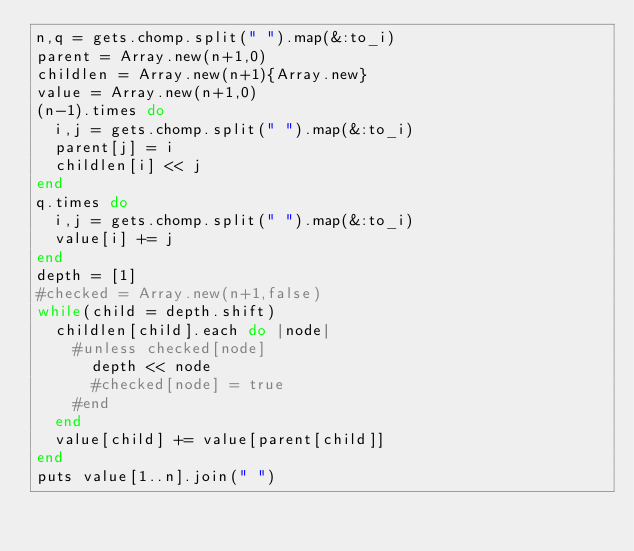Convert code to text. <code><loc_0><loc_0><loc_500><loc_500><_Ruby_>n,q = gets.chomp.split(" ").map(&:to_i)
parent = Array.new(n+1,0)
childlen = Array.new(n+1){Array.new}
value = Array.new(n+1,0)
(n-1).times do
  i,j = gets.chomp.split(" ").map(&:to_i)
  parent[j] = i
  childlen[i] << j
end
q.times do
  i,j = gets.chomp.split(" ").map(&:to_i)
  value[i] += j
end
depth = [1]
#checked = Array.new(n+1,false)
while(child = depth.shift)
  childlen[child].each do |node|
    #unless checked[node]
      depth << node
      #checked[node] = true
    #end
  end
  value[child] += value[parent[child]]
end
puts value[1..n].join(" ")
</code> 